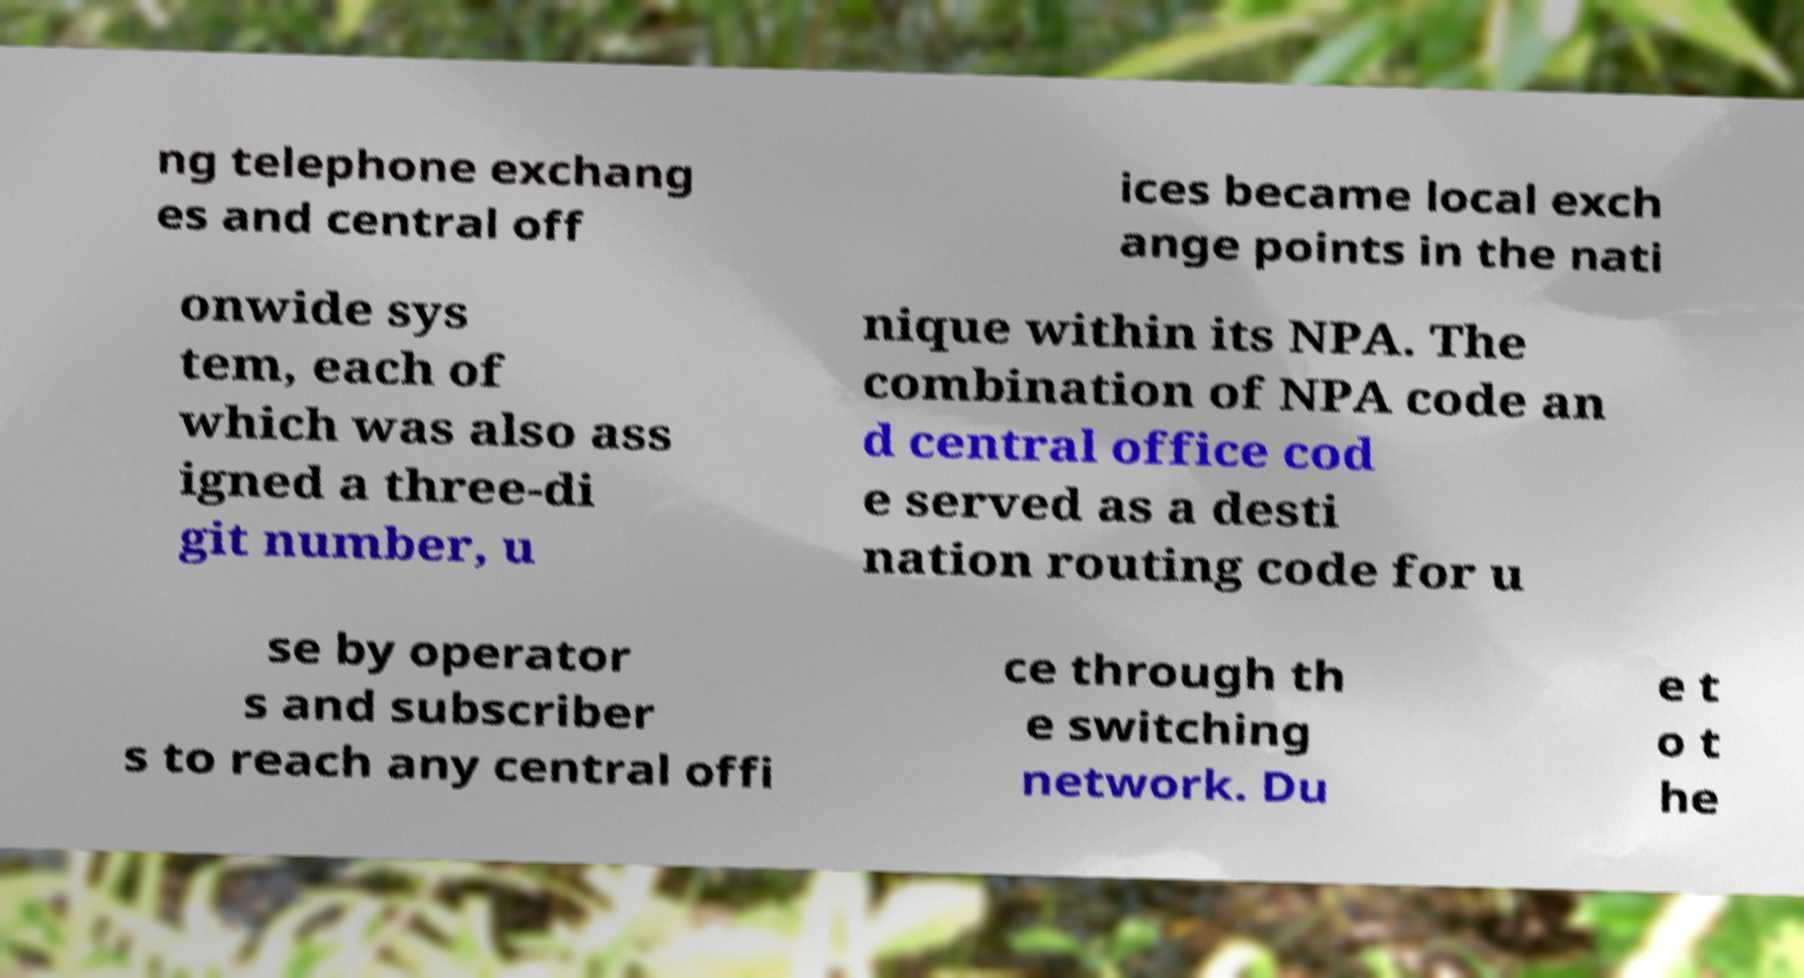Please identify and transcribe the text found in this image. ng telephone exchang es and central off ices became local exch ange points in the nati onwide sys tem, each of which was also ass igned a three-di git number, u nique within its NPA. The combination of NPA code an d central office cod e served as a desti nation routing code for u se by operator s and subscriber s to reach any central offi ce through th e switching network. Du e t o t he 